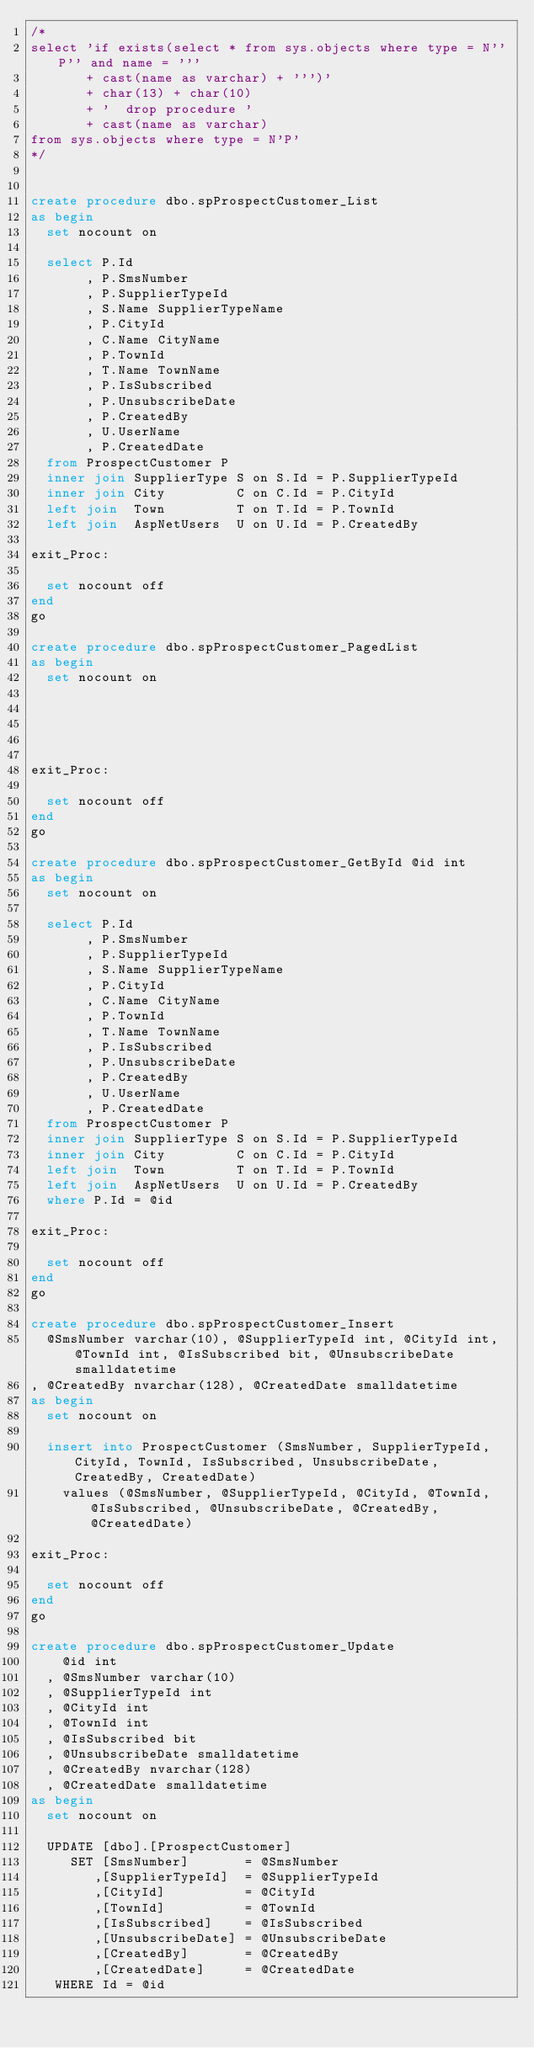<code> <loc_0><loc_0><loc_500><loc_500><_SQL_>/*
select 'if exists(select * from sys.objects where type = N''P'' and name = ''' 
       + cast(name as varchar) + ''')' 
       + char(13) + char(10)
       + '  drop procedure ' 
       + cast(name as varchar)
from sys.objects where type = N'P'
*/


create procedure dbo.spProspectCustomer_List 
as begin
  set nocount on
  
  select P.Id
       , P.SmsNumber
       , P.SupplierTypeId
       , S.Name SupplierTypeName
       , P.CityId
       , C.Name CityName
       , P.TownId
       , T.Name TownName
       , P.IsSubscribed
       , P.UnsubscribeDate
       , P.CreatedBy
       , U.UserName
       , P.CreatedDate
  from ProspectCustomer P
  inner join SupplierType S on S.Id = P.SupplierTypeId
  inner join City         C on C.Id = P.CityId
  left join  Town         T on T.Id = P.TownId
  left join  AspNetUsers  U on U.Id = P.CreatedBy

exit_Proc:

  set nocount off
end  
go

create procedure dbo.spProspectCustomer_PagedList 
as begin
  set nocount on
  
  



exit_Proc:

  set nocount off
end  
go

create procedure dbo.spProspectCustomer_GetById @id int
as begin
  set nocount on
    
  select P.Id
       , P.SmsNumber
       , P.SupplierTypeId
       , S.Name SupplierTypeName
       , P.CityId
       , C.Name CityName
       , P.TownId
       , T.Name TownName
       , P.IsSubscribed
       , P.UnsubscribeDate
       , P.CreatedBy
       , U.UserName
       , P.CreatedDate
  from ProspectCustomer P
  inner join SupplierType S on S.Id = P.SupplierTypeId
  inner join City         C on C.Id = P.CityId
  left join  Town         T on T.Id = P.TownId
  left join  AspNetUsers  U on U.Id = P.CreatedBy
  where P.Id = @id

exit_Proc:

  set nocount off
end  
go

create procedure dbo.spProspectCustomer_Insert
  @SmsNumber varchar(10), @SupplierTypeId int, @CityId int, @TownId int, @IsSubscribed bit, @UnsubscribeDate smalldatetime
, @CreatedBy nvarchar(128), @CreatedDate smalldatetime
as begin
  set nocount on

  insert into ProspectCustomer (SmsNumber, SupplierTypeId, CityId, TownId, IsSubscribed, UnsubscribeDate, CreatedBy, CreatedDate)
    values (@SmsNumber, @SupplierTypeId, @CityId, @TownId, @IsSubscribed, @UnsubscribeDate, @CreatedBy, @CreatedDate)

exit_Proc:

  set nocount off
end  
go

create procedure dbo.spProspectCustomer_Update 
    @id int
  , @SmsNumber varchar(10)
  , @SupplierTypeId int
  , @CityId int
  , @TownId int
  , @IsSubscribed bit
  , @UnsubscribeDate smalldatetime
  , @CreatedBy nvarchar(128)
  , @CreatedDate smalldatetime
as begin
  set nocount on
  
  UPDATE [dbo].[ProspectCustomer]
     SET [SmsNumber]       = @SmsNumber
        ,[SupplierTypeId]  = @SupplierTypeId
        ,[CityId]          = @CityId
        ,[TownId]          = @TownId
        ,[IsSubscribed]    = @IsSubscribed
        ,[UnsubscribeDate] = @UnsubscribeDate
        ,[CreatedBy]       = @CreatedBy
        ,[CreatedDate]     = @CreatedDate
   WHERE Id = @id
</code> 